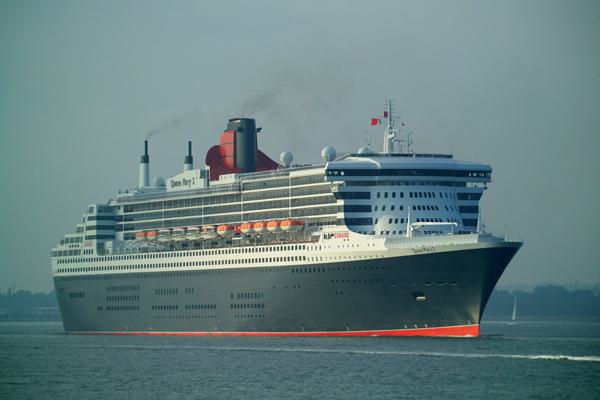How many unicorns would there be in the image after no unicorn was removed in the image? Since there were no unicorns in the original image, and subsequently no unicorns have been removed, there would still be zero unicorns present. 